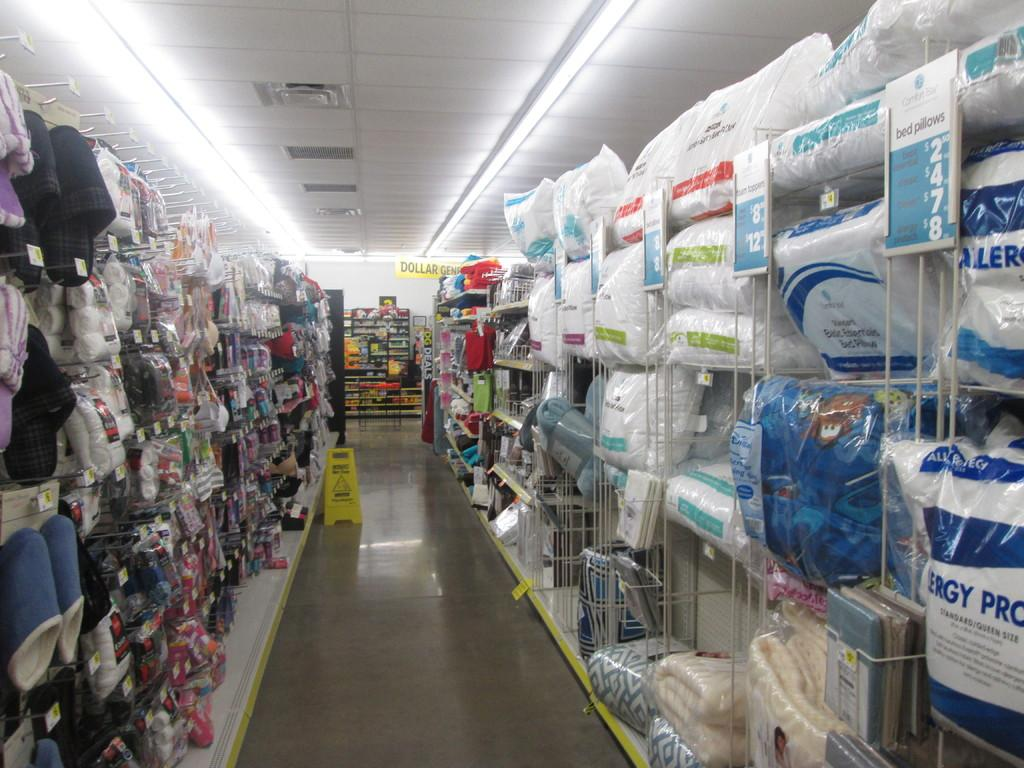<image>
Offer a succinct explanation of the picture presented. The blue sign tells us that pillows range from $2.50 to $8. 